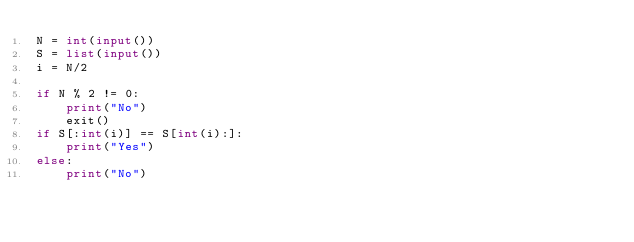<code> <loc_0><loc_0><loc_500><loc_500><_Python_>N = int(input())
S = list(input())
i = N/2

if N % 2 != 0:
    print("No")
    exit()
if S[:int(i)] == S[int(i):]:
    print("Yes")
else:
    print("No")</code> 